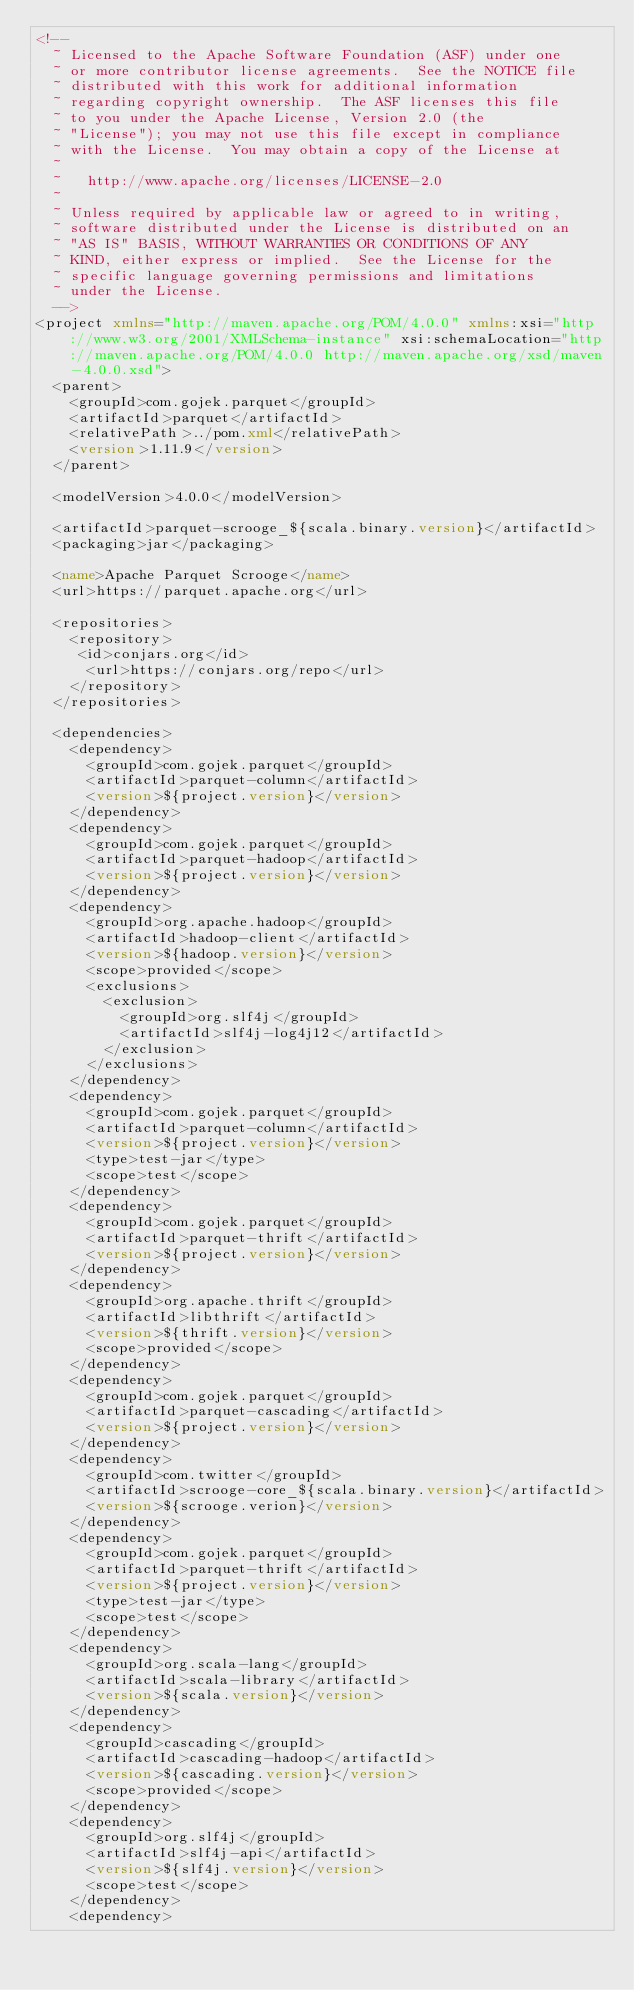Convert code to text. <code><loc_0><loc_0><loc_500><loc_500><_XML_><!--
  ~ Licensed to the Apache Software Foundation (ASF) under one
  ~ or more contributor license agreements.  See the NOTICE file
  ~ distributed with this work for additional information
  ~ regarding copyright ownership.  The ASF licenses this file
  ~ to you under the Apache License, Version 2.0 (the
  ~ "License"); you may not use this file except in compliance
  ~ with the License.  You may obtain a copy of the License at
  ~
  ~   http://www.apache.org/licenses/LICENSE-2.0
  ~
  ~ Unless required by applicable law or agreed to in writing,
  ~ software distributed under the License is distributed on an
  ~ "AS IS" BASIS, WITHOUT WARRANTIES OR CONDITIONS OF ANY
  ~ KIND, either express or implied.  See the License for the
  ~ specific language governing permissions and limitations
  ~ under the License.
  -->
<project xmlns="http://maven.apache.org/POM/4.0.0" xmlns:xsi="http://www.w3.org/2001/XMLSchema-instance" xsi:schemaLocation="http://maven.apache.org/POM/4.0.0 http://maven.apache.org/xsd/maven-4.0.0.xsd">
  <parent>
    <groupId>com.gojek.parquet</groupId>
    <artifactId>parquet</artifactId>
    <relativePath>../pom.xml</relativePath>
    <version>1.11.9</version>
  </parent>

  <modelVersion>4.0.0</modelVersion>

  <artifactId>parquet-scrooge_${scala.binary.version}</artifactId>
  <packaging>jar</packaging>

  <name>Apache Parquet Scrooge</name>
  <url>https://parquet.apache.org</url>

  <repositories>
    <repository>
     <id>conjars.org</id>
      <url>https://conjars.org/repo</url>
    </repository>
  </repositories>

  <dependencies>
    <dependency>
      <groupId>com.gojek.parquet</groupId>
      <artifactId>parquet-column</artifactId>
      <version>${project.version}</version>
    </dependency>
    <dependency>
      <groupId>com.gojek.parquet</groupId>
      <artifactId>parquet-hadoop</artifactId>
      <version>${project.version}</version>
    </dependency>
    <dependency>
      <groupId>org.apache.hadoop</groupId>
      <artifactId>hadoop-client</artifactId>
      <version>${hadoop.version}</version>
      <scope>provided</scope>
      <exclusions>
        <exclusion>
          <groupId>org.slf4j</groupId>
          <artifactId>slf4j-log4j12</artifactId>
        </exclusion>
      </exclusions>
    </dependency>
    <dependency>
      <groupId>com.gojek.parquet</groupId>
      <artifactId>parquet-column</artifactId>
      <version>${project.version}</version>
      <type>test-jar</type>
      <scope>test</scope>
    </dependency>
    <dependency>
      <groupId>com.gojek.parquet</groupId>
      <artifactId>parquet-thrift</artifactId>
      <version>${project.version}</version>
    </dependency>
    <dependency>
      <groupId>org.apache.thrift</groupId>
      <artifactId>libthrift</artifactId>
      <version>${thrift.version}</version>
      <scope>provided</scope>
    </dependency>
    <dependency>
      <groupId>com.gojek.parquet</groupId>
      <artifactId>parquet-cascading</artifactId>
      <version>${project.version}</version>
    </dependency>
    <dependency>
      <groupId>com.twitter</groupId>
      <artifactId>scrooge-core_${scala.binary.version}</artifactId>
      <version>${scrooge.verion}</version>
    </dependency>
    <dependency>
      <groupId>com.gojek.parquet</groupId>
      <artifactId>parquet-thrift</artifactId>
      <version>${project.version}</version>
      <type>test-jar</type>
      <scope>test</scope>
    </dependency>
    <dependency>
      <groupId>org.scala-lang</groupId>
      <artifactId>scala-library</artifactId>
      <version>${scala.version}</version>
    </dependency>
    <dependency>
      <groupId>cascading</groupId>
      <artifactId>cascading-hadoop</artifactId>
      <version>${cascading.version}</version>
      <scope>provided</scope>
    </dependency>
    <dependency>
      <groupId>org.slf4j</groupId>
      <artifactId>slf4j-api</artifactId>
      <version>${slf4j.version}</version>
      <scope>test</scope>
    </dependency>
    <dependency></code> 